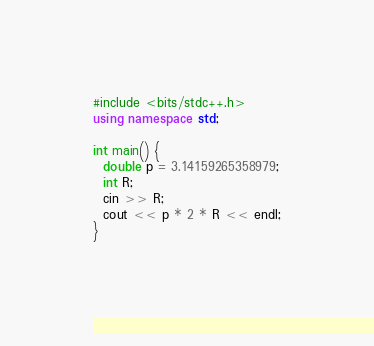Convert code to text. <code><loc_0><loc_0><loc_500><loc_500><_C++_>#include <bits/stdc++.h>
using namespace std;

int main() {
  double p = 3.14159265358979;
  int R;
  cin >> R;
  cout << p * 2 * R << endl;
}
  </code> 